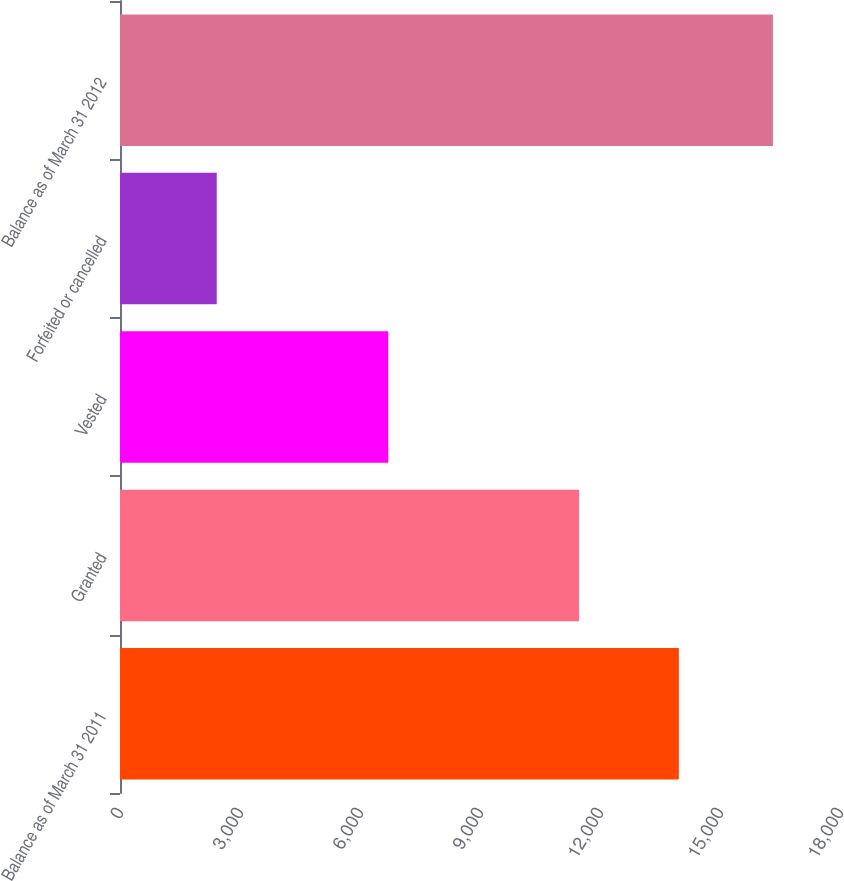Convert chart. <chart><loc_0><loc_0><loc_500><loc_500><bar_chart><fcel>Balance as of March 31 2011<fcel>Granted<fcel>Vested<fcel>Forfeited or cancelled<fcel>Balance as of March 31 2012<nl><fcel>13971<fcel>11478<fcel>6707<fcel>2419<fcel>16323<nl></chart> 